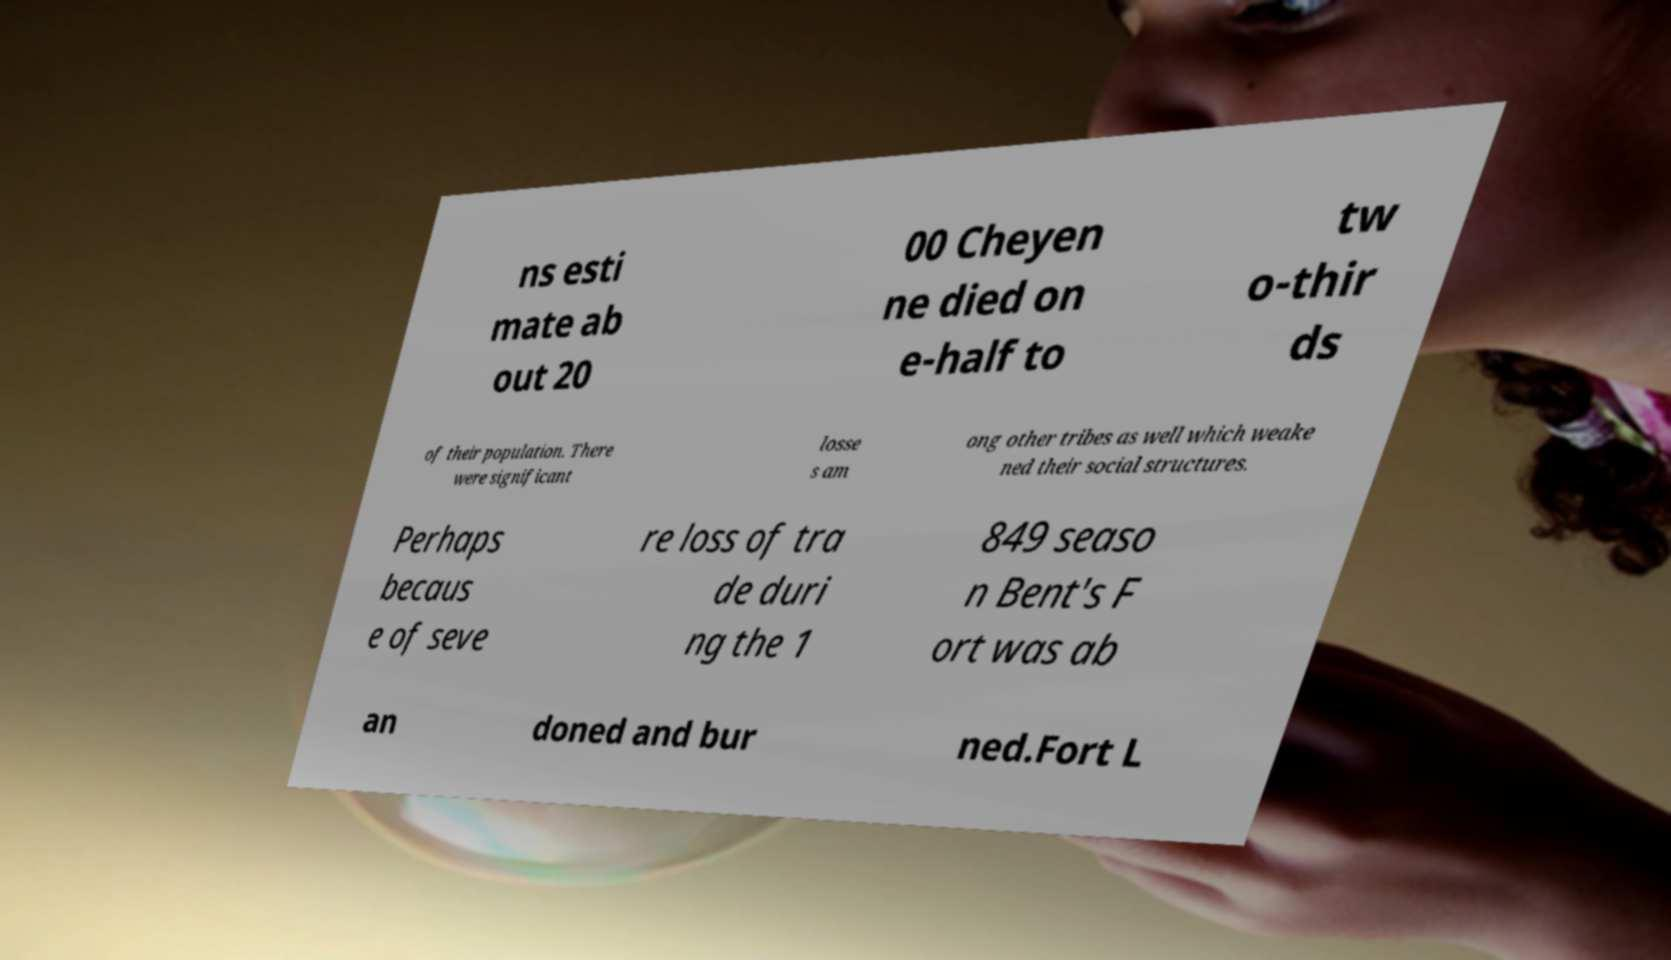Can you read and provide the text displayed in the image?This photo seems to have some interesting text. Can you extract and type it out for me? ns esti mate ab out 20 00 Cheyen ne died on e-half to tw o-thir ds of their population. There were significant losse s am ong other tribes as well which weake ned their social structures. Perhaps becaus e of seve re loss of tra de duri ng the 1 849 seaso n Bent's F ort was ab an doned and bur ned.Fort L 